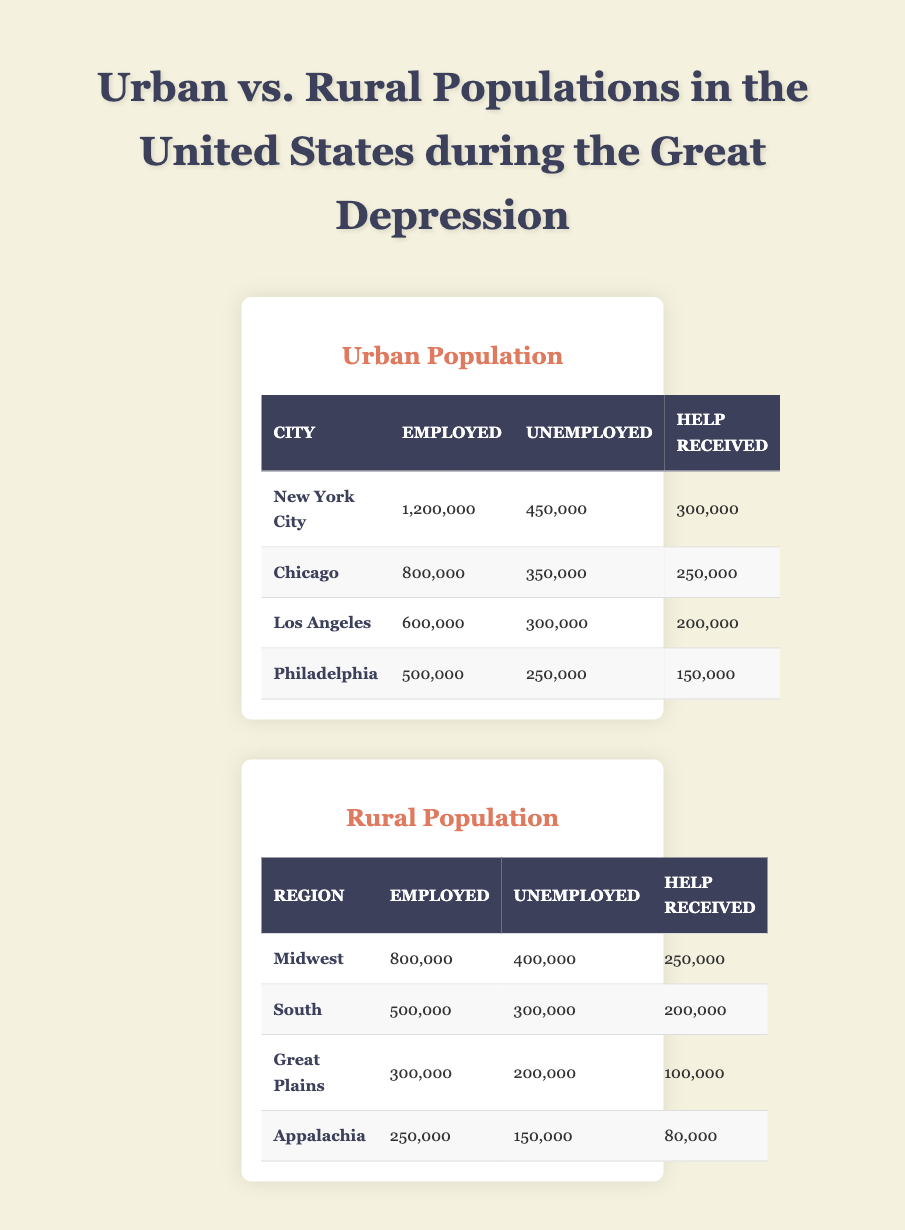What is the total number of employed individuals in urban areas? The total number of employed individuals can be calculated by adding the employed populations from all four cities: New York City (1,200,000) + Chicago (800,000) + Los Angeles (600,000) + Philadelphia (500,000) = 3,100,000.
Answer: 3,100,000 Which city has the highest unemployment rate among the urban populations? To determine the unemployment rate, we need to divide the number of unemployed by the total population (employed + unemployed) for each city. For New York City: 450,000 / (1,200,000 + 450,000) = 0.272 or 27.2%. For Chicago: 350,000 / (800,000 + 350,000) = 0.304 or 30.4%. For Los Angeles: 300,000 / (600,000 + 300,000) = 0.333 or 33.3%. For Philadelphia: 250,000 / (500,000 + 250,000) = 0.333 or 33.3%. The highest rate is in Los Angeles and Philadelphia at 33.3%.
Answer: Los Angeles and Philadelphia Did the rural regions receive more help than the urban areas? The total help received in urban areas is calculated as: 300,000 (New York City) + 250,000 (Chicago) + 200,000 (Los Angeles) + 150,000 (Philadelphia) = 900,000. The total help received in rural regions is: 250,000 (Midwest) + 200,000 (South) + 100,000 (Great Plains) + 80,000 (Appalachia) = 630,000. Since 900,000 > 630,000, urban areas received more help.
Answer: No What is the average number of unemployed individuals in rural regions? To find the average, we must sum the number of unemployed individuals in all rural regions: 400,000 (Midwest) + 300,000 (South) + 200,000 (Great Plains) + 150,000 (Appalachia) = 1,050,000. Since there are 4 regions, the average is 1,050,000 / 4 = 262,500.
Answer: 262,500 Is it true that Chicago has more employed individuals than the total unemployed in the rural areas? Chicago has 800,000 employed individuals. The total number of unemployed individuals in rural areas is: 400,000 (Midwest) + 300,000 (South) + 200,000 (Great Plains) + 150,000 (Appalachia) = 1,050,000. Since 800,000 < 1,050,000, the statement is false.
Answer: No 